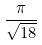Convert formula to latex. <formula><loc_0><loc_0><loc_500><loc_500>\frac { \pi } { \sqrt { 1 8 } }</formula> 